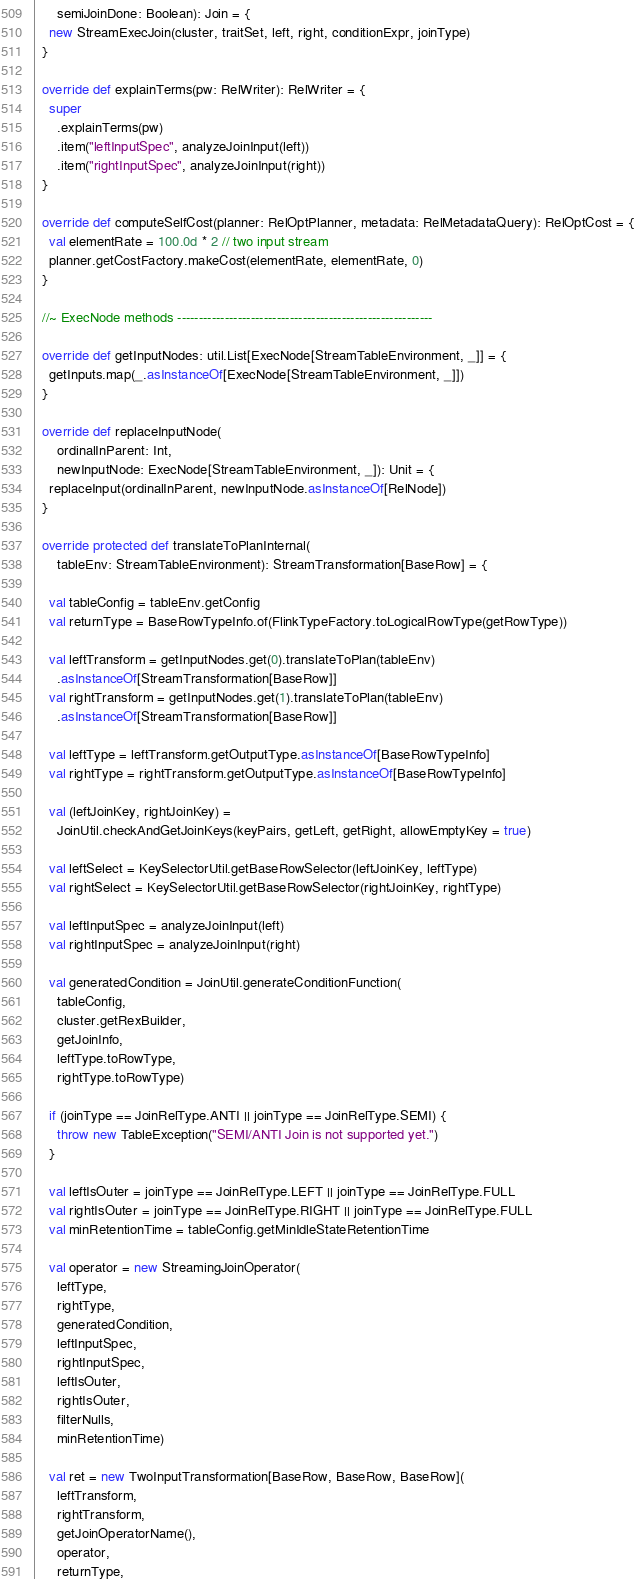Convert code to text. <code><loc_0><loc_0><loc_500><loc_500><_Scala_>      semiJoinDone: Boolean): Join = {
    new StreamExecJoin(cluster, traitSet, left, right, conditionExpr, joinType)
  }

  override def explainTerms(pw: RelWriter): RelWriter = {
    super
      .explainTerms(pw)
      .item("leftInputSpec", analyzeJoinInput(left))
      .item("rightInputSpec", analyzeJoinInput(right))
  }

  override def computeSelfCost(planner: RelOptPlanner, metadata: RelMetadataQuery): RelOptCost = {
    val elementRate = 100.0d * 2 // two input stream
    planner.getCostFactory.makeCost(elementRate, elementRate, 0)
  }

  //~ ExecNode methods -----------------------------------------------------------

  override def getInputNodes: util.List[ExecNode[StreamTableEnvironment, _]] = {
    getInputs.map(_.asInstanceOf[ExecNode[StreamTableEnvironment, _]])
  }

  override def replaceInputNode(
      ordinalInParent: Int,
      newInputNode: ExecNode[StreamTableEnvironment, _]): Unit = {
    replaceInput(ordinalInParent, newInputNode.asInstanceOf[RelNode])
  }

  override protected def translateToPlanInternal(
      tableEnv: StreamTableEnvironment): StreamTransformation[BaseRow] = {

    val tableConfig = tableEnv.getConfig
    val returnType = BaseRowTypeInfo.of(FlinkTypeFactory.toLogicalRowType(getRowType))

    val leftTransform = getInputNodes.get(0).translateToPlan(tableEnv)
      .asInstanceOf[StreamTransformation[BaseRow]]
    val rightTransform = getInputNodes.get(1).translateToPlan(tableEnv)
      .asInstanceOf[StreamTransformation[BaseRow]]

    val leftType = leftTransform.getOutputType.asInstanceOf[BaseRowTypeInfo]
    val rightType = rightTransform.getOutputType.asInstanceOf[BaseRowTypeInfo]

    val (leftJoinKey, rightJoinKey) =
      JoinUtil.checkAndGetJoinKeys(keyPairs, getLeft, getRight, allowEmptyKey = true)

    val leftSelect = KeySelectorUtil.getBaseRowSelector(leftJoinKey, leftType)
    val rightSelect = KeySelectorUtil.getBaseRowSelector(rightJoinKey, rightType)

    val leftInputSpec = analyzeJoinInput(left)
    val rightInputSpec = analyzeJoinInput(right)

    val generatedCondition = JoinUtil.generateConditionFunction(
      tableConfig,
      cluster.getRexBuilder,
      getJoinInfo,
      leftType.toRowType,
      rightType.toRowType)

    if (joinType == JoinRelType.ANTI || joinType == JoinRelType.SEMI) {
      throw new TableException("SEMI/ANTI Join is not supported yet.")
    }

    val leftIsOuter = joinType == JoinRelType.LEFT || joinType == JoinRelType.FULL
    val rightIsOuter = joinType == JoinRelType.RIGHT || joinType == JoinRelType.FULL
    val minRetentionTime = tableConfig.getMinIdleStateRetentionTime

    val operator = new StreamingJoinOperator(
      leftType,
      rightType,
      generatedCondition,
      leftInputSpec,
      rightInputSpec,
      leftIsOuter,
      rightIsOuter,
      filterNulls,
      minRetentionTime)

    val ret = new TwoInputTransformation[BaseRow, BaseRow, BaseRow](
      leftTransform,
      rightTransform,
      getJoinOperatorName(),
      operator,
      returnType,</code> 